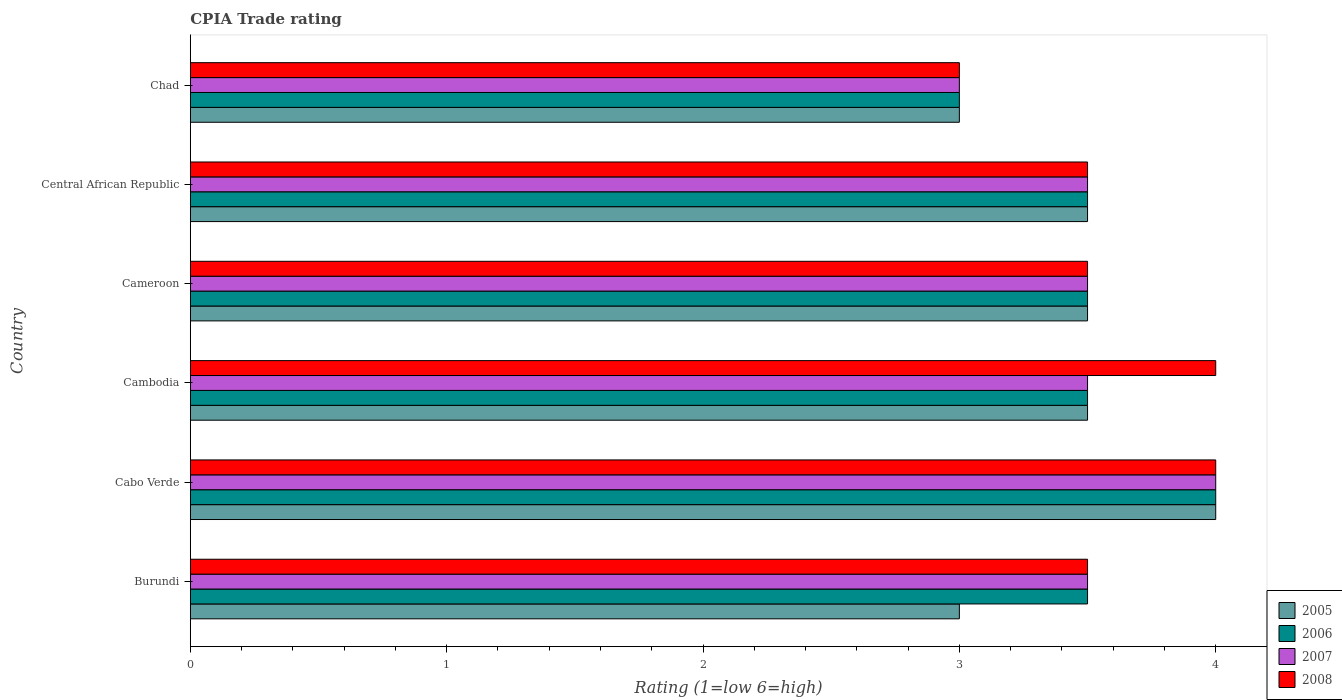How many different coloured bars are there?
Keep it short and to the point. 4. How many groups of bars are there?
Provide a succinct answer. 6. Are the number of bars on each tick of the Y-axis equal?
Ensure brevity in your answer.  Yes. How many bars are there on the 6th tick from the top?
Ensure brevity in your answer.  4. How many bars are there on the 5th tick from the bottom?
Provide a succinct answer. 4. What is the label of the 3rd group of bars from the top?
Ensure brevity in your answer.  Cameroon. In how many cases, is the number of bars for a given country not equal to the number of legend labels?
Offer a very short reply. 0. In which country was the CPIA rating in 2008 maximum?
Ensure brevity in your answer.  Cabo Verde. In which country was the CPIA rating in 2008 minimum?
Keep it short and to the point. Chad. What is the difference between the CPIA rating in 2008 in Burundi and the CPIA rating in 2005 in Central African Republic?
Offer a very short reply. 0. What is the difference between the CPIA rating in 2005 and CPIA rating in 2007 in Central African Republic?
Provide a short and direct response. 0. What is the ratio of the CPIA rating in 2006 in Burundi to that in Cameroon?
Keep it short and to the point. 1. Is the CPIA rating in 2006 in Cabo Verde less than that in Cambodia?
Keep it short and to the point. No. Is the difference between the CPIA rating in 2005 in Burundi and Chad greater than the difference between the CPIA rating in 2007 in Burundi and Chad?
Provide a succinct answer. No. What is the difference between the highest and the second highest CPIA rating in 2005?
Provide a short and direct response. 0.5. What is the difference between the highest and the lowest CPIA rating in 2008?
Your answer should be very brief. 1. Is it the case that in every country, the sum of the CPIA rating in 2005 and CPIA rating in 2006 is greater than the sum of CPIA rating in 2007 and CPIA rating in 2008?
Offer a very short reply. No. What does the 2nd bar from the top in Central African Republic represents?
Your answer should be very brief. 2007. Are all the bars in the graph horizontal?
Give a very brief answer. Yes. What is the difference between two consecutive major ticks on the X-axis?
Keep it short and to the point. 1. Does the graph contain any zero values?
Make the answer very short. No. Where does the legend appear in the graph?
Offer a very short reply. Bottom right. What is the title of the graph?
Provide a short and direct response. CPIA Trade rating. What is the Rating (1=low 6=high) of 2006 in Burundi?
Give a very brief answer. 3.5. What is the Rating (1=low 6=high) in 2007 in Burundi?
Offer a terse response. 3.5. What is the Rating (1=low 6=high) of 2008 in Burundi?
Your answer should be very brief. 3.5. What is the Rating (1=low 6=high) in 2005 in Cabo Verde?
Offer a terse response. 4. What is the Rating (1=low 6=high) in 2007 in Cabo Verde?
Give a very brief answer. 4. What is the Rating (1=low 6=high) of 2008 in Cabo Verde?
Ensure brevity in your answer.  4. What is the Rating (1=low 6=high) in 2006 in Cambodia?
Your answer should be very brief. 3.5. What is the Rating (1=low 6=high) of 2007 in Cambodia?
Keep it short and to the point. 3.5. What is the Rating (1=low 6=high) of 2008 in Cambodia?
Offer a very short reply. 4. What is the Rating (1=low 6=high) of 2008 in Cameroon?
Provide a short and direct response. 3.5. What is the Rating (1=low 6=high) of 2005 in Chad?
Your answer should be very brief. 3. What is the Rating (1=low 6=high) in 2006 in Chad?
Keep it short and to the point. 3. What is the Rating (1=low 6=high) of 2007 in Chad?
Provide a short and direct response. 3. Across all countries, what is the maximum Rating (1=low 6=high) of 2005?
Offer a very short reply. 4. Across all countries, what is the maximum Rating (1=low 6=high) of 2006?
Ensure brevity in your answer.  4. Across all countries, what is the maximum Rating (1=low 6=high) in 2007?
Ensure brevity in your answer.  4. Across all countries, what is the maximum Rating (1=low 6=high) of 2008?
Your response must be concise. 4. What is the total Rating (1=low 6=high) of 2008 in the graph?
Ensure brevity in your answer.  21.5. What is the difference between the Rating (1=low 6=high) of 2005 in Burundi and that in Cabo Verde?
Keep it short and to the point. -1. What is the difference between the Rating (1=low 6=high) of 2007 in Burundi and that in Cabo Verde?
Give a very brief answer. -0.5. What is the difference between the Rating (1=low 6=high) of 2006 in Burundi and that in Cambodia?
Make the answer very short. 0. What is the difference between the Rating (1=low 6=high) of 2005 in Burundi and that in Cameroon?
Provide a short and direct response. -0.5. What is the difference between the Rating (1=low 6=high) of 2006 in Burundi and that in Cameroon?
Provide a succinct answer. 0. What is the difference between the Rating (1=low 6=high) of 2007 in Burundi and that in Cameroon?
Provide a succinct answer. 0. What is the difference between the Rating (1=low 6=high) of 2008 in Burundi and that in Cameroon?
Your answer should be very brief. 0. What is the difference between the Rating (1=low 6=high) in 2006 in Burundi and that in Central African Republic?
Your answer should be compact. 0. What is the difference between the Rating (1=low 6=high) of 2008 in Burundi and that in Central African Republic?
Your response must be concise. 0. What is the difference between the Rating (1=low 6=high) of 2008 in Burundi and that in Chad?
Your answer should be compact. 0.5. What is the difference between the Rating (1=low 6=high) in 2006 in Cabo Verde and that in Cambodia?
Provide a short and direct response. 0.5. What is the difference between the Rating (1=low 6=high) of 2006 in Cabo Verde and that in Cameroon?
Give a very brief answer. 0.5. What is the difference between the Rating (1=low 6=high) of 2005 in Cabo Verde and that in Central African Republic?
Offer a terse response. 0.5. What is the difference between the Rating (1=low 6=high) in 2008 in Cabo Verde and that in Central African Republic?
Your answer should be very brief. 0.5. What is the difference between the Rating (1=low 6=high) in 2005 in Cabo Verde and that in Chad?
Keep it short and to the point. 1. What is the difference between the Rating (1=low 6=high) of 2007 in Cabo Verde and that in Chad?
Your response must be concise. 1. What is the difference between the Rating (1=low 6=high) in 2005 in Cambodia and that in Cameroon?
Your answer should be compact. 0. What is the difference between the Rating (1=low 6=high) in 2006 in Cambodia and that in Cameroon?
Ensure brevity in your answer.  0. What is the difference between the Rating (1=low 6=high) in 2007 in Cambodia and that in Cameroon?
Keep it short and to the point. 0. What is the difference between the Rating (1=low 6=high) in 2006 in Cambodia and that in Chad?
Your answer should be compact. 0.5. What is the difference between the Rating (1=low 6=high) of 2005 in Cameroon and that in Central African Republic?
Ensure brevity in your answer.  0. What is the difference between the Rating (1=low 6=high) of 2006 in Cameroon and that in Central African Republic?
Offer a very short reply. 0. What is the difference between the Rating (1=low 6=high) of 2007 in Cameroon and that in Central African Republic?
Ensure brevity in your answer.  0. What is the difference between the Rating (1=low 6=high) in 2008 in Cameroon and that in Central African Republic?
Provide a succinct answer. 0. What is the difference between the Rating (1=low 6=high) in 2006 in Cameroon and that in Chad?
Ensure brevity in your answer.  0.5. What is the difference between the Rating (1=low 6=high) in 2008 in Cameroon and that in Chad?
Offer a very short reply. 0.5. What is the difference between the Rating (1=low 6=high) of 2005 in Central African Republic and that in Chad?
Ensure brevity in your answer.  0.5. What is the difference between the Rating (1=low 6=high) of 2008 in Central African Republic and that in Chad?
Offer a very short reply. 0.5. What is the difference between the Rating (1=low 6=high) in 2005 in Burundi and the Rating (1=low 6=high) in 2007 in Cabo Verde?
Offer a very short reply. -1. What is the difference between the Rating (1=low 6=high) of 2005 in Burundi and the Rating (1=low 6=high) of 2008 in Cabo Verde?
Keep it short and to the point. -1. What is the difference between the Rating (1=low 6=high) in 2006 in Burundi and the Rating (1=low 6=high) in 2007 in Cabo Verde?
Your answer should be compact. -0.5. What is the difference between the Rating (1=low 6=high) in 2006 in Burundi and the Rating (1=low 6=high) in 2008 in Cabo Verde?
Give a very brief answer. -0.5. What is the difference between the Rating (1=low 6=high) of 2007 in Burundi and the Rating (1=low 6=high) of 2008 in Cabo Verde?
Your answer should be very brief. -0.5. What is the difference between the Rating (1=low 6=high) in 2005 in Burundi and the Rating (1=low 6=high) in 2006 in Cambodia?
Ensure brevity in your answer.  -0.5. What is the difference between the Rating (1=low 6=high) of 2005 in Burundi and the Rating (1=low 6=high) of 2007 in Cambodia?
Your response must be concise. -0.5. What is the difference between the Rating (1=low 6=high) in 2005 in Burundi and the Rating (1=low 6=high) in 2008 in Cambodia?
Make the answer very short. -1. What is the difference between the Rating (1=low 6=high) in 2006 in Burundi and the Rating (1=low 6=high) in 2007 in Cambodia?
Your response must be concise. 0. What is the difference between the Rating (1=low 6=high) in 2006 in Burundi and the Rating (1=low 6=high) in 2008 in Cambodia?
Offer a terse response. -0.5. What is the difference between the Rating (1=low 6=high) in 2007 in Burundi and the Rating (1=low 6=high) in 2008 in Cambodia?
Give a very brief answer. -0.5. What is the difference between the Rating (1=low 6=high) of 2006 in Burundi and the Rating (1=low 6=high) of 2008 in Cameroon?
Your answer should be compact. 0. What is the difference between the Rating (1=low 6=high) in 2007 in Burundi and the Rating (1=low 6=high) in 2008 in Cameroon?
Your response must be concise. 0. What is the difference between the Rating (1=low 6=high) in 2005 in Burundi and the Rating (1=low 6=high) in 2006 in Central African Republic?
Keep it short and to the point. -0.5. What is the difference between the Rating (1=low 6=high) of 2005 in Burundi and the Rating (1=low 6=high) of 2008 in Central African Republic?
Make the answer very short. -0.5. What is the difference between the Rating (1=low 6=high) of 2006 in Burundi and the Rating (1=low 6=high) of 2008 in Central African Republic?
Your answer should be very brief. 0. What is the difference between the Rating (1=low 6=high) of 2007 in Burundi and the Rating (1=low 6=high) of 2008 in Central African Republic?
Provide a short and direct response. 0. What is the difference between the Rating (1=low 6=high) in 2005 in Burundi and the Rating (1=low 6=high) in 2007 in Chad?
Your answer should be very brief. 0. What is the difference between the Rating (1=low 6=high) in 2006 in Burundi and the Rating (1=low 6=high) in 2007 in Chad?
Keep it short and to the point. 0.5. What is the difference between the Rating (1=low 6=high) of 2006 in Burundi and the Rating (1=low 6=high) of 2008 in Chad?
Make the answer very short. 0.5. What is the difference between the Rating (1=low 6=high) in 2005 in Cabo Verde and the Rating (1=low 6=high) in 2006 in Cambodia?
Offer a very short reply. 0.5. What is the difference between the Rating (1=low 6=high) in 2005 in Cabo Verde and the Rating (1=low 6=high) in 2007 in Cambodia?
Make the answer very short. 0.5. What is the difference between the Rating (1=low 6=high) of 2006 in Cabo Verde and the Rating (1=low 6=high) of 2008 in Cambodia?
Offer a terse response. 0. What is the difference between the Rating (1=low 6=high) in 2005 in Cabo Verde and the Rating (1=low 6=high) in 2006 in Cameroon?
Make the answer very short. 0.5. What is the difference between the Rating (1=low 6=high) of 2005 in Cabo Verde and the Rating (1=low 6=high) of 2007 in Central African Republic?
Provide a short and direct response. 0.5. What is the difference between the Rating (1=low 6=high) of 2006 in Cabo Verde and the Rating (1=low 6=high) of 2008 in Central African Republic?
Your answer should be compact. 0.5. What is the difference between the Rating (1=low 6=high) of 2005 in Cabo Verde and the Rating (1=low 6=high) of 2006 in Chad?
Your response must be concise. 1. What is the difference between the Rating (1=low 6=high) in 2005 in Cabo Verde and the Rating (1=low 6=high) in 2007 in Chad?
Ensure brevity in your answer.  1. What is the difference between the Rating (1=low 6=high) of 2006 in Cabo Verde and the Rating (1=low 6=high) of 2008 in Chad?
Give a very brief answer. 1. What is the difference between the Rating (1=low 6=high) in 2007 in Cabo Verde and the Rating (1=low 6=high) in 2008 in Chad?
Your answer should be very brief. 1. What is the difference between the Rating (1=low 6=high) of 2005 in Cambodia and the Rating (1=low 6=high) of 2006 in Cameroon?
Provide a short and direct response. 0. What is the difference between the Rating (1=low 6=high) of 2005 in Cambodia and the Rating (1=low 6=high) of 2007 in Cameroon?
Offer a very short reply. 0. What is the difference between the Rating (1=low 6=high) of 2007 in Cambodia and the Rating (1=low 6=high) of 2008 in Cameroon?
Give a very brief answer. 0. What is the difference between the Rating (1=low 6=high) in 2006 in Cambodia and the Rating (1=low 6=high) in 2008 in Central African Republic?
Your response must be concise. 0. What is the difference between the Rating (1=low 6=high) of 2006 in Cambodia and the Rating (1=low 6=high) of 2007 in Chad?
Your answer should be compact. 0.5. What is the difference between the Rating (1=low 6=high) in 2005 in Cameroon and the Rating (1=low 6=high) in 2008 in Central African Republic?
Offer a very short reply. 0. What is the difference between the Rating (1=low 6=high) of 2006 in Cameroon and the Rating (1=low 6=high) of 2007 in Central African Republic?
Your answer should be very brief. 0. What is the difference between the Rating (1=low 6=high) in 2005 in Cameroon and the Rating (1=low 6=high) in 2006 in Chad?
Offer a very short reply. 0.5. What is the difference between the Rating (1=low 6=high) in 2006 in Cameroon and the Rating (1=low 6=high) in 2007 in Chad?
Provide a short and direct response. 0.5. What is the difference between the Rating (1=low 6=high) of 2006 in Cameroon and the Rating (1=low 6=high) of 2008 in Chad?
Offer a terse response. 0.5. What is the difference between the Rating (1=low 6=high) of 2007 in Cameroon and the Rating (1=low 6=high) of 2008 in Chad?
Keep it short and to the point. 0.5. What is the difference between the Rating (1=low 6=high) of 2005 in Central African Republic and the Rating (1=low 6=high) of 2007 in Chad?
Your response must be concise. 0.5. What is the difference between the Rating (1=low 6=high) in 2005 in Central African Republic and the Rating (1=low 6=high) in 2008 in Chad?
Offer a very short reply. 0.5. What is the average Rating (1=low 6=high) in 2005 per country?
Ensure brevity in your answer.  3.42. What is the average Rating (1=low 6=high) of 2007 per country?
Your answer should be very brief. 3.5. What is the average Rating (1=low 6=high) in 2008 per country?
Your answer should be very brief. 3.58. What is the difference between the Rating (1=low 6=high) in 2005 and Rating (1=low 6=high) in 2006 in Burundi?
Offer a terse response. -0.5. What is the difference between the Rating (1=low 6=high) of 2005 and Rating (1=low 6=high) of 2006 in Cabo Verde?
Your answer should be compact. 0. What is the difference between the Rating (1=low 6=high) of 2005 and Rating (1=low 6=high) of 2008 in Cabo Verde?
Offer a very short reply. 0. What is the difference between the Rating (1=low 6=high) in 2006 and Rating (1=low 6=high) in 2008 in Cabo Verde?
Ensure brevity in your answer.  0. What is the difference between the Rating (1=low 6=high) in 2005 and Rating (1=low 6=high) in 2006 in Cambodia?
Provide a succinct answer. 0. What is the difference between the Rating (1=low 6=high) in 2005 and Rating (1=low 6=high) in 2007 in Cambodia?
Your answer should be very brief. 0. What is the difference between the Rating (1=low 6=high) of 2006 and Rating (1=low 6=high) of 2007 in Cambodia?
Your answer should be very brief. 0. What is the difference between the Rating (1=low 6=high) of 2006 and Rating (1=low 6=high) of 2008 in Cambodia?
Offer a terse response. -0.5. What is the difference between the Rating (1=low 6=high) of 2005 and Rating (1=low 6=high) of 2006 in Cameroon?
Keep it short and to the point. 0. What is the difference between the Rating (1=low 6=high) in 2006 and Rating (1=low 6=high) in 2007 in Cameroon?
Give a very brief answer. 0. What is the difference between the Rating (1=low 6=high) of 2007 and Rating (1=low 6=high) of 2008 in Cameroon?
Your response must be concise. 0. What is the difference between the Rating (1=low 6=high) of 2005 and Rating (1=low 6=high) of 2008 in Central African Republic?
Provide a short and direct response. 0. What is the difference between the Rating (1=low 6=high) of 2006 and Rating (1=low 6=high) of 2008 in Central African Republic?
Offer a terse response. 0. What is the difference between the Rating (1=low 6=high) of 2005 and Rating (1=low 6=high) of 2006 in Chad?
Offer a very short reply. 0. What is the difference between the Rating (1=low 6=high) of 2006 and Rating (1=low 6=high) of 2007 in Chad?
Keep it short and to the point. 0. What is the difference between the Rating (1=low 6=high) in 2006 and Rating (1=low 6=high) in 2008 in Chad?
Make the answer very short. 0. What is the ratio of the Rating (1=low 6=high) of 2006 in Burundi to that in Cabo Verde?
Provide a short and direct response. 0.88. What is the ratio of the Rating (1=low 6=high) in 2007 in Burundi to that in Cabo Verde?
Offer a very short reply. 0.88. What is the ratio of the Rating (1=low 6=high) of 2005 in Burundi to that in Cambodia?
Your answer should be very brief. 0.86. What is the ratio of the Rating (1=low 6=high) of 2008 in Burundi to that in Cambodia?
Provide a succinct answer. 0.88. What is the ratio of the Rating (1=low 6=high) of 2008 in Burundi to that in Cameroon?
Your response must be concise. 1. What is the ratio of the Rating (1=low 6=high) of 2006 in Burundi to that in Chad?
Ensure brevity in your answer.  1.17. What is the ratio of the Rating (1=low 6=high) of 2008 in Burundi to that in Chad?
Keep it short and to the point. 1.17. What is the ratio of the Rating (1=low 6=high) in 2005 in Cabo Verde to that in Cambodia?
Provide a short and direct response. 1.14. What is the ratio of the Rating (1=low 6=high) in 2006 in Cabo Verde to that in Cambodia?
Offer a very short reply. 1.14. What is the ratio of the Rating (1=low 6=high) of 2005 in Cabo Verde to that in Cameroon?
Give a very brief answer. 1.14. What is the ratio of the Rating (1=low 6=high) of 2007 in Cabo Verde to that in Cameroon?
Give a very brief answer. 1.14. What is the ratio of the Rating (1=low 6=high) in 2005 in Cabo Verde to that in Central African Republic?
Make the answer very short. 1.14. What is the ratio of the Rating (1=low 6=high) of 2007 in Cabo Verde to that in Central African Republic?
Your answer should be compact. 1.14. What is the ratio of the Rating (1=low 6=high) of 2005 in Cabo Verde to that in Chad?
Give a very brief answer. 1.33. What is the ratio of the Rating (1=low 6=high) in 2006 in Cabo Verde to that in Chad?
Ensure brevity in your answer.  1.33. What is the ratio of the Rating (1=low 6=high) of 2007 in Cabo Verde to that in Chad?
Your answer should be very brief. 1.33. What is the ratio of the Rating (1=low 6=high) in 2005 in Cambodia to that in Cameroon?
Your answer should be compact. 1. What is the ratio of the Rating (1=low 6=high) in 2006 in Cambodia to that in Cameroon?
Your answer should be very brief. 1. What is the ratio of the Rating (1=low 6=high) of 2008 in Cambodia to that in Cameroon?
Your response must be concise. 1.14. What is the ratio of the Rating (1=low 6=high) in 2006 in Cambodia to that in Central African Republic?
Ensure brevity in your answer.  1. What is the ratio of the Rating (1=low 6=high) of 2006 in Cambodia to that in Chad?
Provide a short and direct response. 1.17. What is the ratio of the Rating (1=low 6=high) of 2007 in Cambodia to that in Chad?
Your answer should be very brief. 1.17. What is the ratio of the Rating (1=low 6=high) of 2007 in Cameroon to that in Central African Republic?
Ensure brevity in your answer.  1. What is the ratio of the Rating (1=low 6=high) of 2008 in Cameroon to that in Central African Republic?
Give a very brief answer. 1. What is the ratio of the Rating (1=low 6=high) of 2005 in Cameroon to that in Chad?
Keep it short and to the point. 1.17. What is the ratio of the Rating (1=low 6=high) of 2007 in Cameroon to that in Chad?
Offer a terse response. 1.17. What is the ratio of the Rating (1=low 6=high) of 2008 in Cameroon to that in Chad?
Your answer should be compact. 1.17. What is the difference between the highest and the lowest Rating (1=low 6=high) of 2005?
Give a very brief answer. 1. 